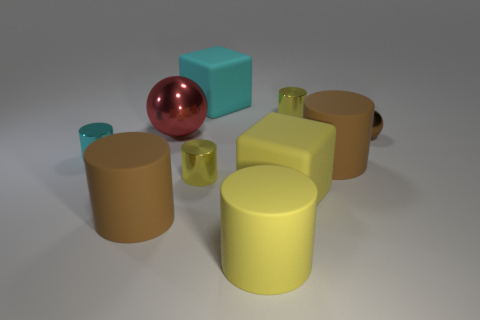Subtract all purple spheres. How many yellow cylinders are left? 3 Subtract 1 cylinders. How many cylinders are left? 5 Subtract all big brown cylinders. How many cylinders are left? 4 Subtract all cyan cylinders. How many cylinders are left? 5 Subtract all purple cylinders. Subtract all yellow balls. How many cylinders are left? 6 Subtract all cylinders. How many objects are left? 4 Add 2 big red metal spheres. How many big red metal spheres are left? 3 Add 4 large shiny objects. How many large shiny objects exist? 5 Subtract 2 yellow cylinders. How many objects are left? 8 Subtract all tiny yellow cylinders. Subtract all metal objects. How many objects are left? 3 